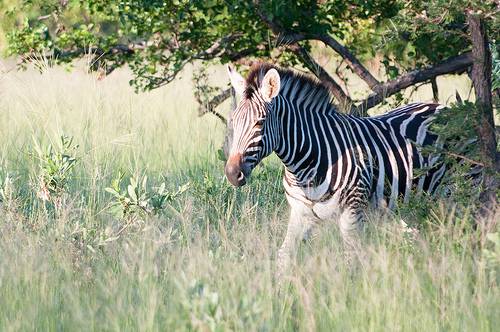Please provide the bounding box coordinate of the region this sentence describes: black mane on zebra. The bounding box coordinates for the zebra's black mane are [0.47, 0.25, 0.67, 0.36]. This area likely encompasses the mane along with part of the zebra’s head and neck. 